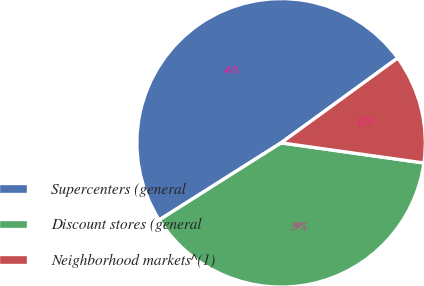<chart> <loc_0><loc_0><loc_500><loc_500><pie_chart><fcel>Supercenters (general<fcel>Discount stores (general<fcel>Neighborhood markets^(1)<nl><fcel>48.96%<fcel>38.79%<fcel>12.24%<nl></chart> 